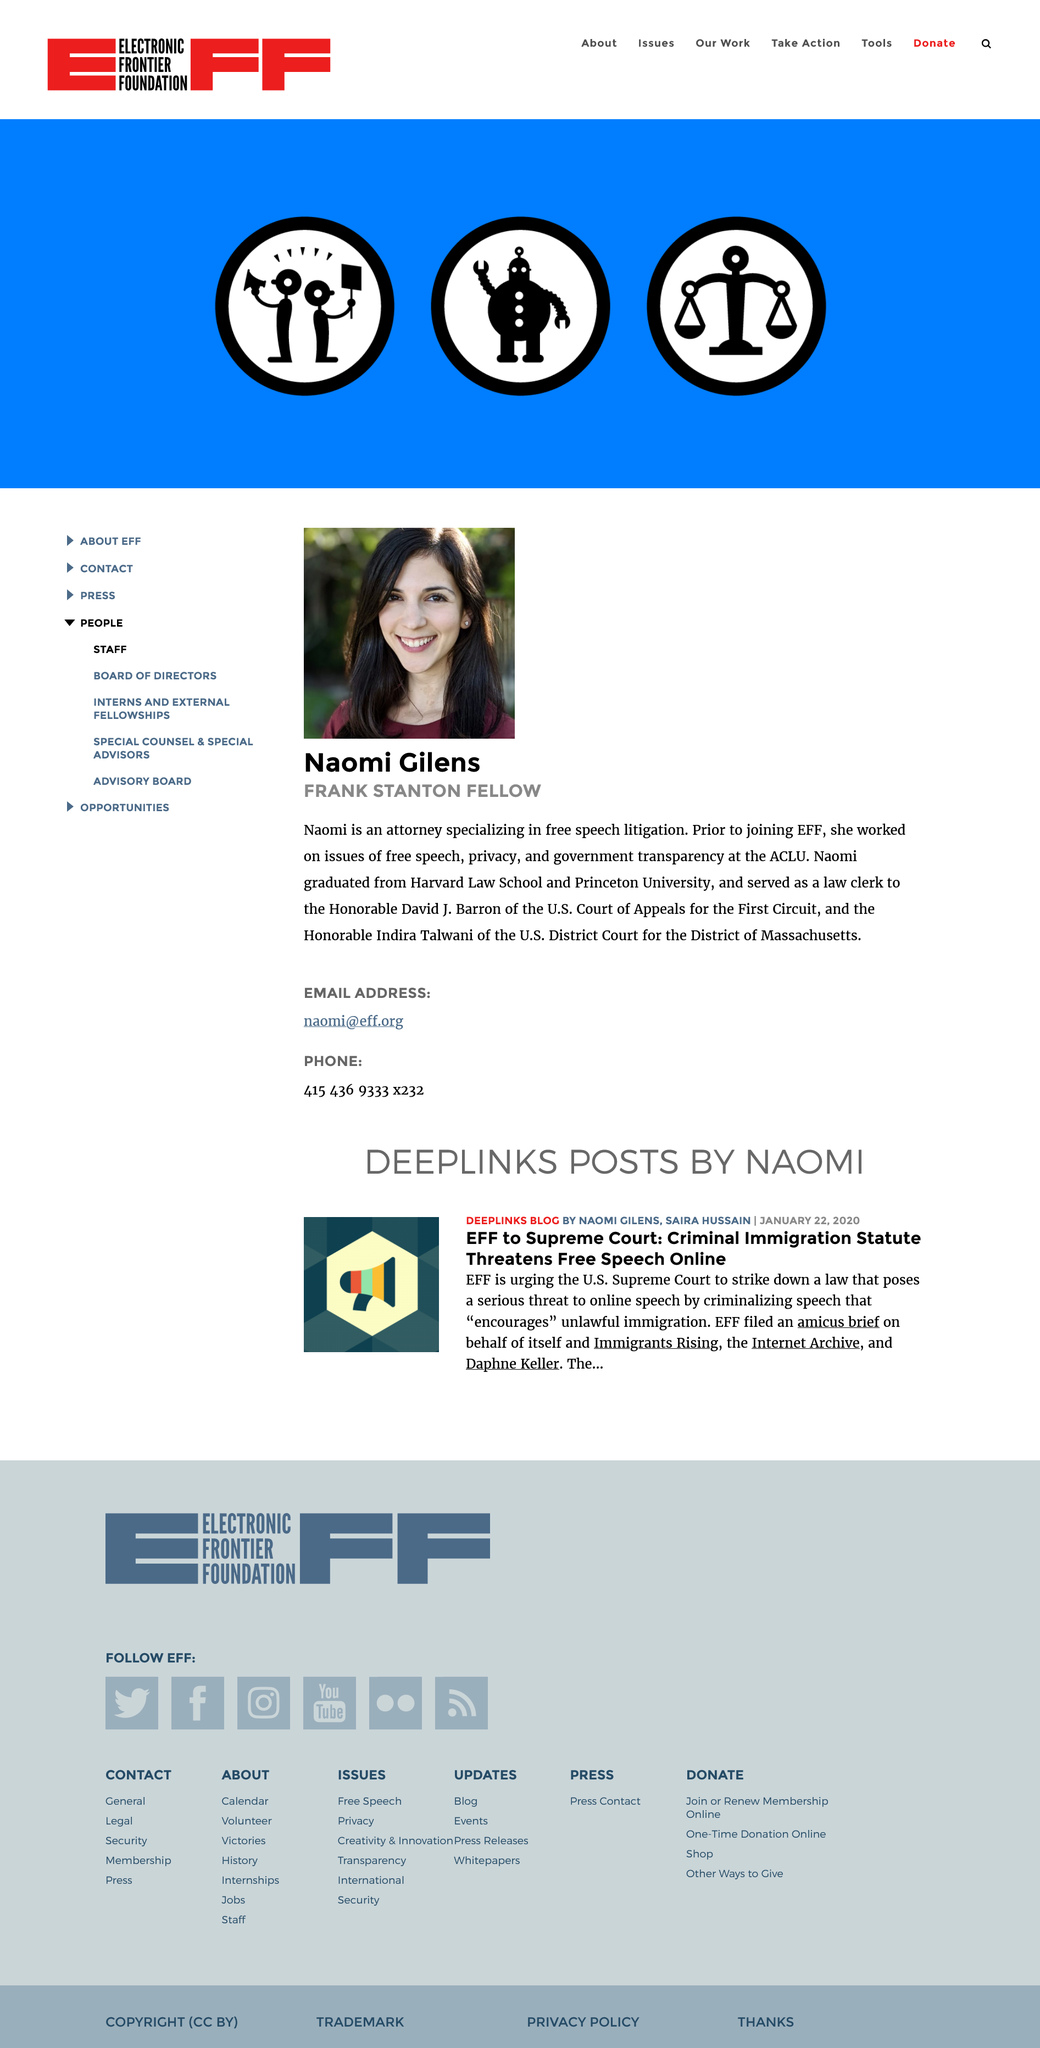List a handful of essential elements in this visual. Naomi Gilens is a Frank Stanton Fellow. The subject of the sentence is "What is Naomi Gilen's email address?" and the predicate is "Naomi Gilen's email address is naomi@eff.org. 